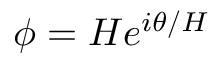<formula> <loc_0><loc_0><loc_500><loc_500>\phi = H e ^ { i \theta / H }</formula> 